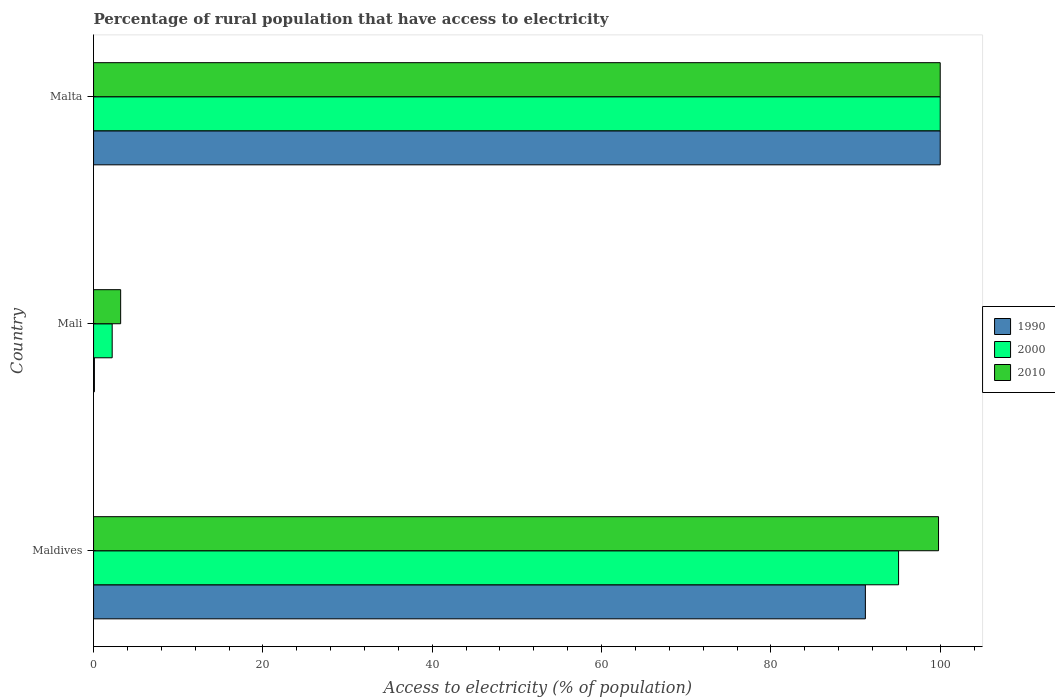How many different coloured bars are there?
Give a very brief answer. 3. How many groups of bars are there?
Provide a short and direct response. 3. Are the number of bars per tick equal to the number of legend labels?
Provide a succinct answer. Yes. How many bars are there on the 2nd tick from the top?
Keep it short and to the point. 3. What is the label of the 2nd group of bars from the top?
Keep it short and to the point. Mali. What is the percentage of rural population that have access to electricity in 2000 in Mali?
Give a very brief answer. 2.2. Across all countries, what is the minimum percentage of rural population that have access to electricity in 1990?
Ensure brevity in your answer.  0.1. In which country was the percentage of rural population that have access to electricity in 2000 maximum?
Offer a terse response. Malta. In which country was the percentage of rural population that have access to electricity in 2000 minimum?
Make the answer very short. Mali. What is the total percentage of rural population that have access to electricity in 2010 in the graph?
Give a very brief answer. 203. What is the difference between the percentage of rural population that have access to electricity in 2000 in Maldives and that in Mali?
Offer a very short reply. 92.88. What is the difference between the percentage of rural population that have access to electricity in 1990 in Malta and the percentage of rural population that have access to electricity in 2010 in Maldives?
Make the answer very short. 0.2. What is the average percentage of rural population that have access to electricity in 2000 per country?
Offer a terse response. 65.76. What is the difference between the percentage of rural population that have access to electricity in 2010 and percentage of rural population that have access to electricity in 2000 in Mali?
Keep it short and to the point. 1. In how many countries, is the percentage of rural population that have access to electricity in 1990 greater than 44 %?
Offer a terse response. 2. What is the difference between the highest and the second highest percentage of rural population that have access to electricity in 2000?
Make the answer very short. 4.92. What is the difference between the highest and the lowest percentage of rural population that have access to electricity in 2010?
Provide a succinct answer. 96.8. What does the 3rd bar from the top in Maldives represents?
Your answer should be compact. 1990. Is it the case that in every country, the sum of the percentage of rural population that have access to electricity in 2000 and percentage of rural population that have access to electricity in 2010 is greater than the percentage of rural population that have access to electricity in 1990?
Give a very brief answer. Yes. How many bars are there?
Offer a very short reply. 9. How many legend labels are there?
Offer a terse response. 3. How are the legend labels stacked?
Provide a succinct answer. Vertical. What is the title of the graph?
Provide a short and direct response. Percentage of rural population that have access to electricity. What is the label or title of the X-axis?
Keep it short and to the point. Access to electricity (% of population). What is the Access to electricity (% of population) of 1990 in Maldives?
Ensure brevity in your answer.  91.16. What is the Access to electricity (% of population) of 2000 in Maldives?
Keep it short and to the point. 95.08. What is the Access to electricity (% of population) of 2010 in Maldives?
Provide a succinct answer. 99.8. What is the Access to electricity (% of population) of 2010 in Mali?
Keep it short and to the point. 3.2. What is the Access to electricity (% of population) in 2000 in Malta?
Your answer should be very brief. 100. Across all countries, what is the maximum Access to electricity (% of population) in 2000?
Provide a short and direct response. 100. Across all countries, what is the maximum Access to electricity (% of population) in 2010?
Your response must be concise. 100. Across all countries, what is the minimum Access to electricity (% of population) in 2010?
Your answer should be very brief. 3.2. What is the total Access to electricity (% of population) in 1990 in the graph?
Provide a short and direct response. 191.26. What is the total Access to electricity (% of population) of 2000 in the graph?
Offer a very short reply. 197.28. What is the total Access to electricity (% of population) in 2010 in the graph?
Provide a short and direct response. 203. What is the difference between the Access to electricity (% of population) of 1990 in Maldives and that in Mali?
Offer a very short reply. 91.06. What is the difference between the Access to electricity (% of population) of 2000 in Maldives and that in Mali?
Give a very brief answer. 92.88. What is the difference between the Access to electricity (% of population) in 2010 in Maldives and that in Mali?
Provide a short and direct response. 96.6. What is the difference between the Access to electricity (% of population) in 1990 in Maldives and that in Malta?
Keep it short and to the point. -8.84. What is the difference between the Access to electricity (% of population) of 2000 in Maldives and that in Malta?
Provide a succinct answer. -4.92. What is the difference between the Access to electricity (% of population) in 1990 in Mali and that in Malta?
Your answer should be very brief. -99.9. What is the difference between the Access to electricity (% of population) in 2000 in Mali and that in Malta?
Make the answer very short. -97.8. What is the difference between the Access to electricity (% of population) of 2010 in Mali and that in Malta?
Make the answer very short. -96.8. What is the difference between the Access to electricity (% of population) in 1990 in Maldives and the Access to electricity (% of population) in 2000 in Mali?
Give a very brief answer. 88.96. What is the difference between the Access to electricity (% of population) of 1990 in Maldives and the Access to electricity (% of population) of 2010 in Mali?
Your answer should be compact. 87.96. What is the difference between the Access to electricity (% of population) of 2000 in Maldives and the Access to electricity (% of population) of 2010 in Mali?
Ensure brevity in your answer.  91.88. What is the difference between the Access to electricity (% of population) in 1990 in Maldives and the Access to electricity (% of population) in 2000 in Malta?
Offer a very short reply. -8.84. What is the difference between the Access to electricity (% of population) of 1990 in Maldives and the Access to electricity (% of population) of 2010 in Malta?
Keep it short and to the point. -8.84. What is the difference between the Access to electricity (% of population) in 2000 in Maldives and the Access to electricity (% of population) in 2010 in Malta?
Keep it short and to the point. -4.92. What is the difference between the Access to electricity (% of population) of 1990 in Mali and the Access to electricity (% of population) of 2000 in Malta?
Provide a short and direct response. -99.9. What is the difference between the Access to electricity (% of population) in 1990 in Mali and the Access to electricity (% of population) in 2010 in Malta?
Give a very brief answer. -99.9. What is the difference between the Access to electricity (% of population) of 2000 in Mali and the Access to electricity (% of population) of 2010 in Malta?
Keep it short and to the point. -97.8. What is the average Access to electricity (% of population) of 1990 per country?
Give a very brief answer. 63.75. What is the average Access to electricity (% of population) of 2000 per country?
Provide a succinct answer. 65.76. What is the average Access to electricity (% of population) of 2010 per country?
Your answer should be very brief. 67.67. What is the difference between the Access to electricity (% of population) in 1990 and Access to electricity (% of population) in 2000 in Maldives?
Ensure brevity in your answer.  -3.92. What is the difference between the Access to electricity (% of population) of 1990 and Access to electricity (% of population) of 2010 in Maldives?
Make the answer very short. -8.64. What is the difference between the Access to electricity (% of population) in 2000 and Access to electricity (% of population) in 2010 in Maldives?
Give a very brief answer. -4.72. What is the difference between the Access to electricity (% of population) of 2000 and Access to electricity (% of population) of 2010 in Malta?
Your response must be concise. 0. What is the ratio of the Access to electricity (% of population) in 1990 in Maldives to that in Mali?
Ensure brevity in your answer.  911.6. What is the ratio of the Access to electricity (% of population) of 2000 in Maldives to that in Mali?
Keep it short and to the point. 43.22. What is the ratio of the Access to electricity (% of population) in 2010 in Maldives to that in Mali?
Ensure brevity in your answer.  31.19. What is the ratio of the Access to electricity (% of population) of 1990 in Maldives to that in Malta?
Give a very brief answer. 0.91. What is the ratio of the Access to electricity (% of population) of 2000 in Maldives to that in Malta?
Make the answer very short. 0.95. What is the ratio of the Access to electricity (% of population) of 2010 in Maldives to that in Malta?
Your answer should be very brief. 1. What is the ratio of the Access to electricity (% of population) in 2000 in Mali to that in Malta?
Provide a succinct answer. 0.02. What is the ratio of the Access to electricity (% of population) of 2010 in Mali to that in Malta?
Make the answer very short. 0.03. What is the difference between the highest and the second highest Access to electricity (% of population) of 1990?
Make the answer very short. 8.84. What is the difference between the highest and the second highest Access to electricity (% of population) in 2000?
Your answer should be very brief. 4.92. What is the difference between the highest and the second highest Access to electricity (% of population) of 2010?
Your answer should be very brief. 0.2. What is the difference between the highest and the lowest Access to electricity (% of population) of 1990?
Offer a very short reply. 99.9. What is the difference between the highest and the lowest Access to electricity (% of population) in 2000?
Keep it short and to the point. 97.8. What is the difference between the highest and the lowest Access to electricity (% of population) of 2010?
Provide a succinct answer. 96.8. 